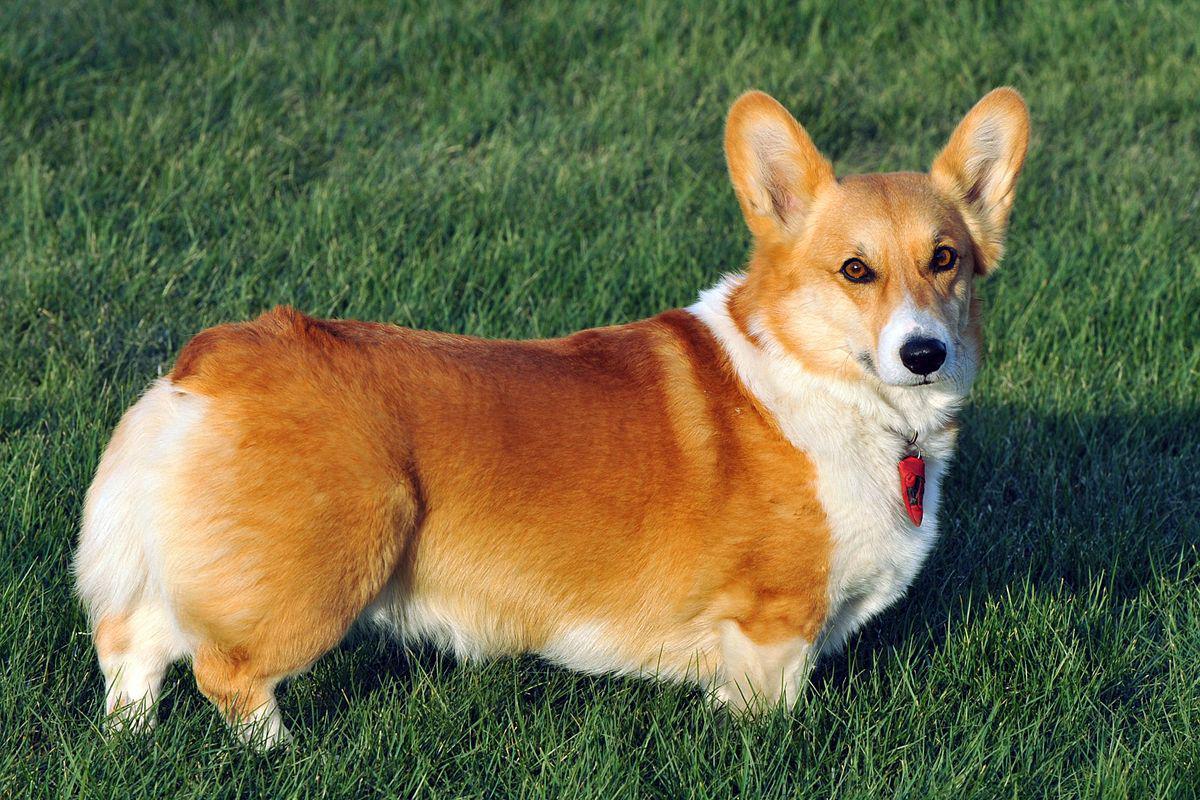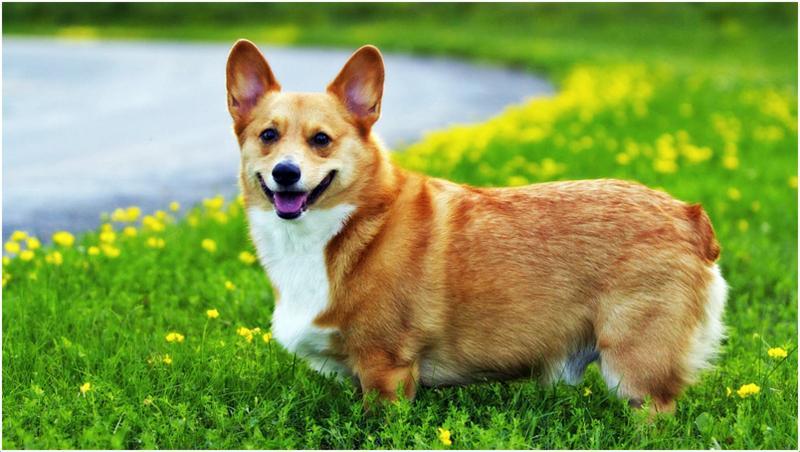The first image is the image on the left, the second image is the image on the right. Evaluate the accuracy of this statement regarding the images: "The bodies of both dogs are facing the right.". Is it true? Answer yes or no. No. 